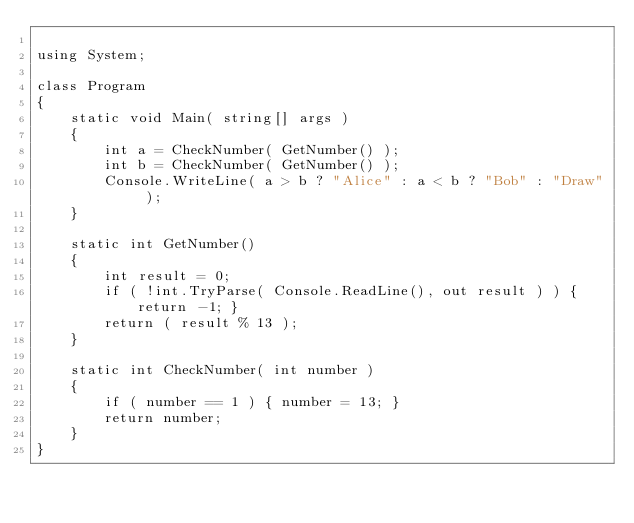<code> <loc_0><loc_0><loc_500><loc_500><_C#_>
using System;

class Program
{
    static void Main( string[] args )
    {
        int a = CheckNumber( GetNumber() );
        int b = CheckNumber( GetNumber() );
        Console.WriteLine( a > b ? "Alice" : a < b ? "Bob" : "Draw" );
    }

    static int GetNumber()
    {
        int result = 0;
        if ( !int.TryParse( Console.ReadLine(), out result ) ) { return -1; }
        return ( result % 13 );
    }

    static int CheckNumber( int number )
    {
        if ( number == 1 ) { number = 13; }
        return number;
    }
}
</code> 